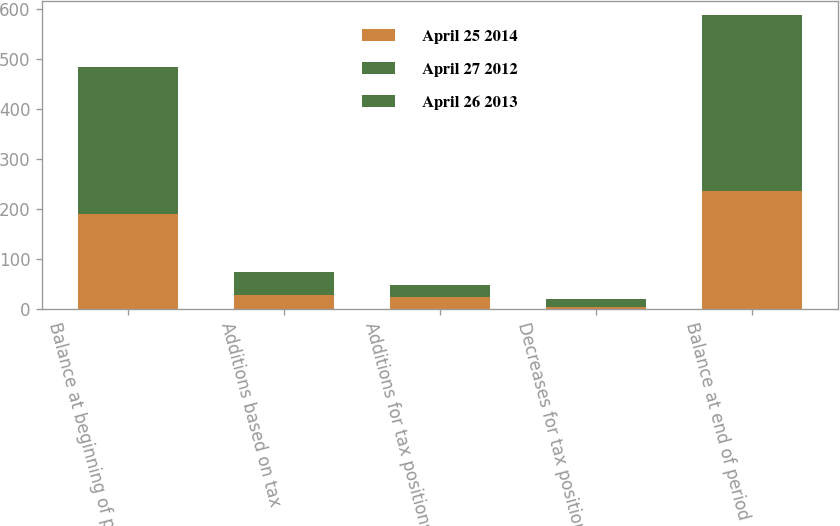<chart> <loc_0><loc_0><loc_500><loc_500><stacked_bar_chart><ecel><fcel>Balance at beginning of period<fcel>Additions based on tax<fcel>Additions for tax positions of<fcel>Decreases for tax positions of<fcel>Balance at end of period<nl><fcel>April 25 2014<fcel>189.6<fcel>26.9<fcel>23.8<fcel>4.4<fcel>235.9<nl><fcel>April 27 2012<fcel>161<fcel>34.5<fcel>1<fcel>6.9<fcel>189.6<nl><fcel>April 26 2013<fcel>133.3<fcel>13<fcel>22.1<fcel>7.4<fcel>161<nl></chart> 